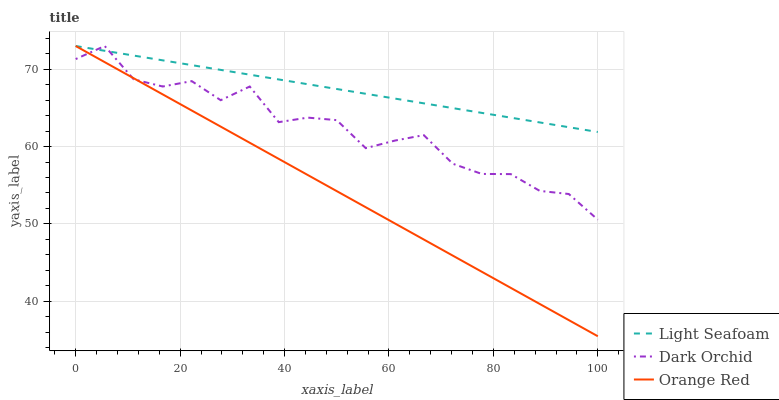Does Orange Red have the minimum area under the curve?
Answer yes or no. Yes. Does Light Seafoam have the maximum area under the curve?
Answer yes or no. Yes. Does Dark Orchid have the minimum area under the curve?
Answer yes or no. No. Does Dark Orchid have the maximum area under the curve?
Answer yes or no. No. Is Light Seafoam the smoothest?
Answer yes or no. Yes. Is Dark Orchid the roughest?
Answer yes or no. Yes. Is Orange Red the smoothest?
Answer yes or no. No. Is Orange Red the roughest?
Answer yes or no. No. Does Orange Red have the lowest value?
Answer yes or no. Yes. Does Dark Orchid have the lowest value?
Answer yes or no. No. Does Dark Orchid have the highest value?
Answer yes or no. Yes. Does Dark Orchid intersect Light Seafoam?
Answer yes or no. Yes. Is Dark Orchid less than Light Seafoam?
Answer yes or no. No. Is Dark Orchid greater than Light Seafoam?
Answer yes or no. No. 